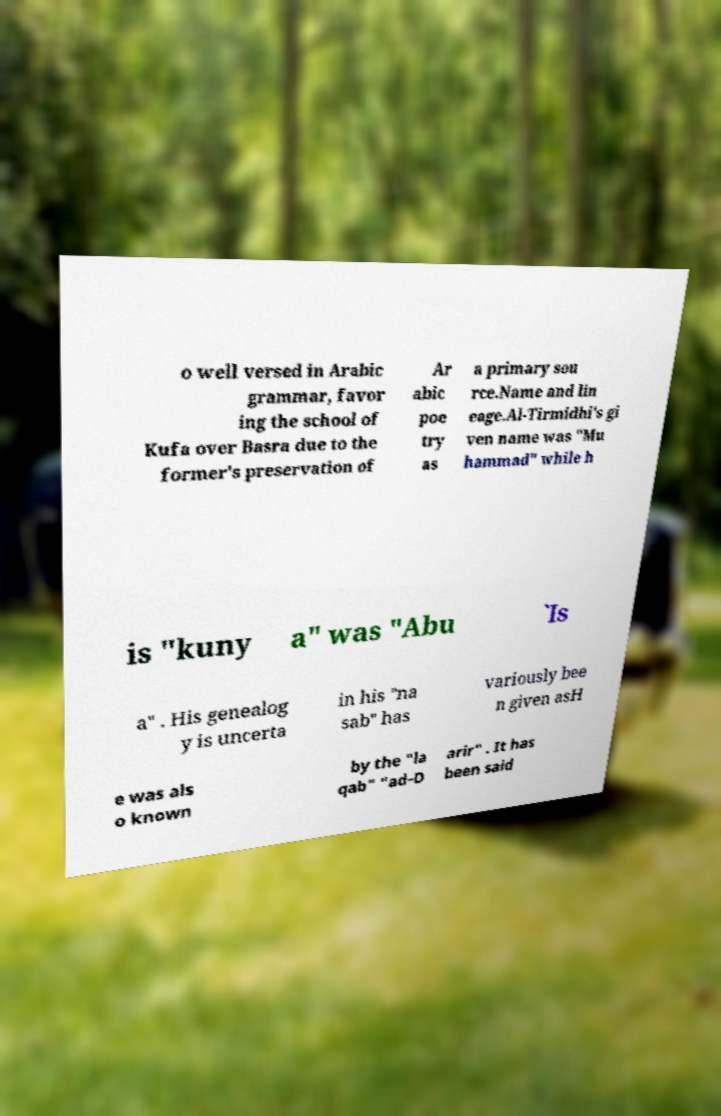What messages or text are displayed in this image? I need them in a readable, typed format. o well versed in Arabic grammar, favor ing the school of Kufa over Basra due to the former's preservation of Ar abic poe try as a primary sou rce.Name and lin eage.Al-Tirmidhi's gi ven name was "Mu hammad" while h is "kuny a" was "Abu `Is a" . His genealog y is uncerta in his "na sab" has variously bee n given asH e was als o known by the "la qab" "ad-D arir" . It has been said 